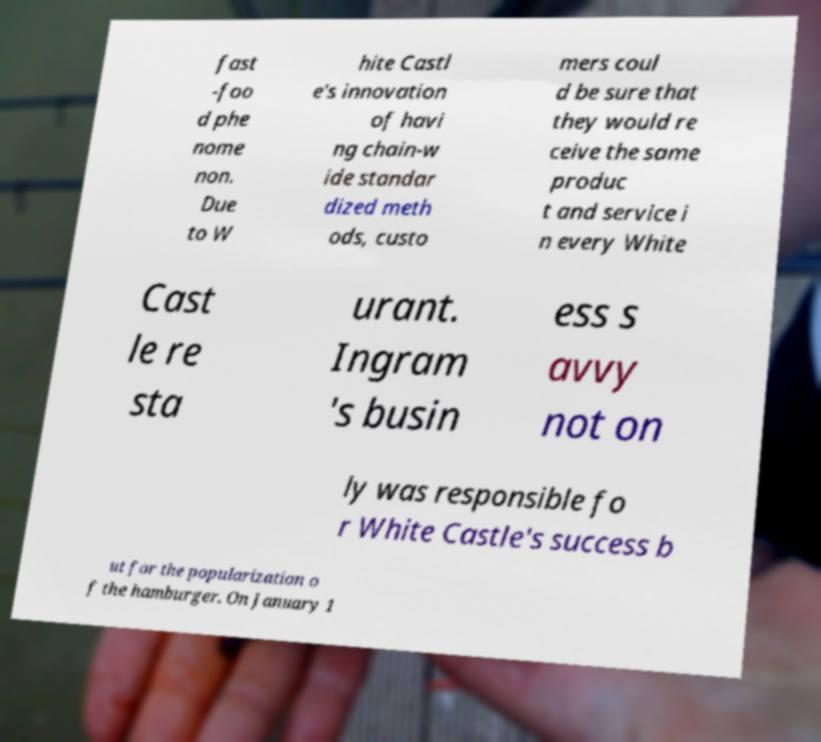I need the written content from this picture converted into text. Can you do that? fast -foo d phe nome non. Due to W hite Castl e's innovation of havi ng chain-w ide standar dized meth ods, custo mers coul d be sure that they would re ceive the same produc t and service i n every White Cast le re sta urant. Ingram 's busin ess s avvy not on ly was responsible fo r White Castle's success b ut for the popularization o f the hamburger. On January 1 